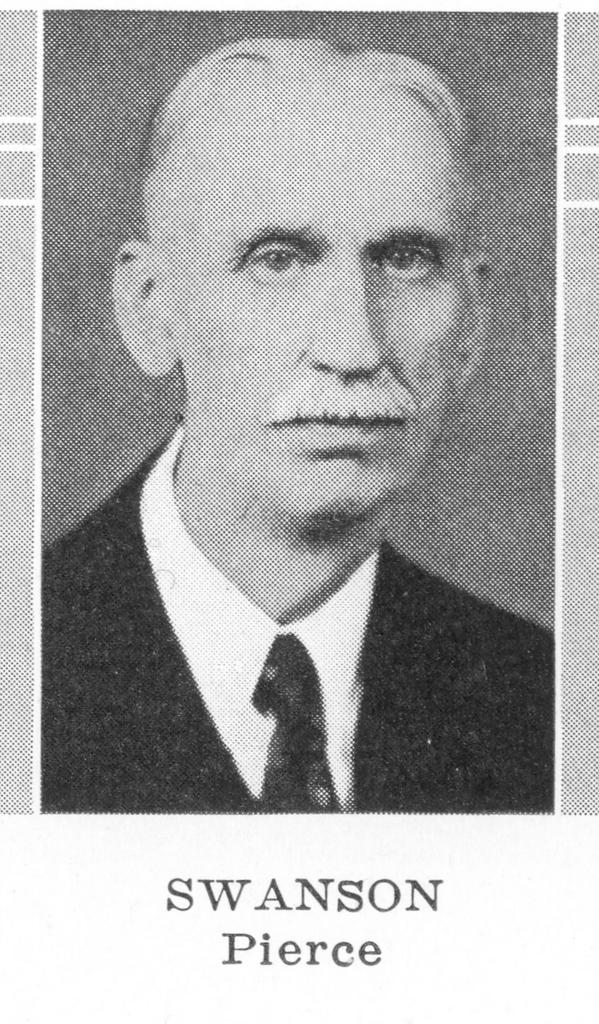What is the color scheme of the image? The image is black and white. Can you describe the main subject of the image? There is a person in the image. Is there any text present in the image? Yes, there is text at the bottom of the image. How many beggars are visible in the image? There is no mention of a beggar in the image, and therefore no such figure can be observed. 